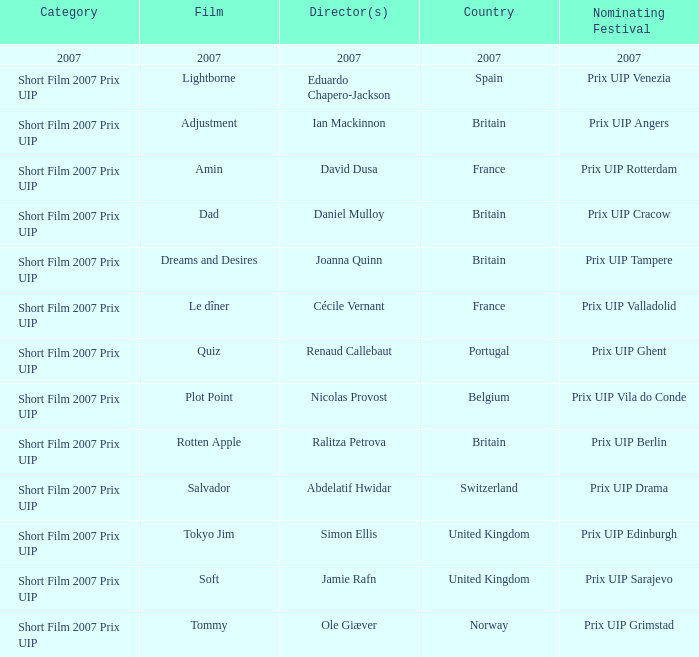What film was filmed in Spain? Lightborne. 